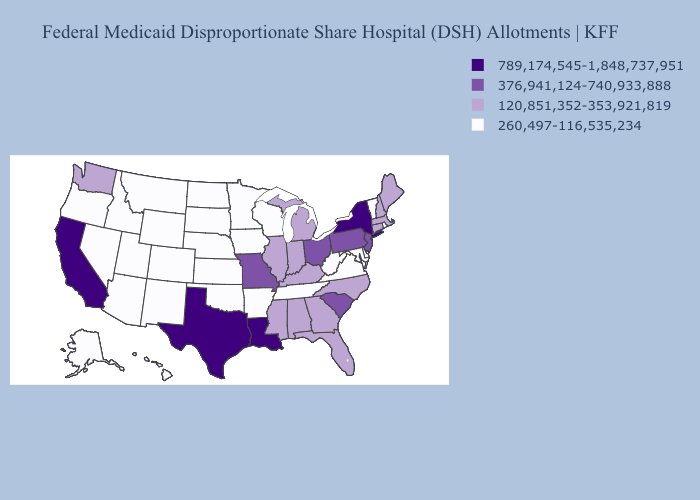What is the value of North Dakota?
Short answer required. 260,497-116,535,234. Among the states that border Nevada , does California have the lowest value?
Be succinct. No. Name the states that have a value in the range 120,851,352-353,921,819?
Give a very brief answer. Alabama, Connecticut, Florida, Georgia, Illinois, Indiana, Kentucky, Maine, Massachusetts, Michigan, Mississippi, New Hampshire, North Carolina, Washington. What is the lowest value in the USA?
Be succinct. 260,497-116,535,234. Does Louisiana have the same value as Texas?
Keep it brief. Yes. What is the highest value in the USA?
Give a very brief answer. 789,174,545-1,848,737,951. Does the first symbol in the legend represent the smallest category?
Keep it brief. No. What is the value of Kansas?
Give a very brief answer. 260,497-116,535,234. Does Rhode Island have the highest value in the USA?
Give a very brief answer. No. What is the value of New York?
Short answer required. 789,174,545-1,848,737,951. Name the states that have a value in the range 789,174,545-1,848,737,951?
Answer briefly. California, Louisiana, New York, Texas. What is the value of Nevada?
Give a very brief answer. 260,497-116,535,234. Name the states that have a value in the range 376,941,124-740,933,888?
Write a very short answer. Missouri, New Jersey, Ohio, Pennsylvania, South Carolina. Name the states that have a value in the range 376,941,124-740,933,888?
Concise answer only. Missouri, New Jersey, Ohio, Pennsylvania, South Carolina. Does Connecticut have a lower value than Florida?
Be succinct. No. 